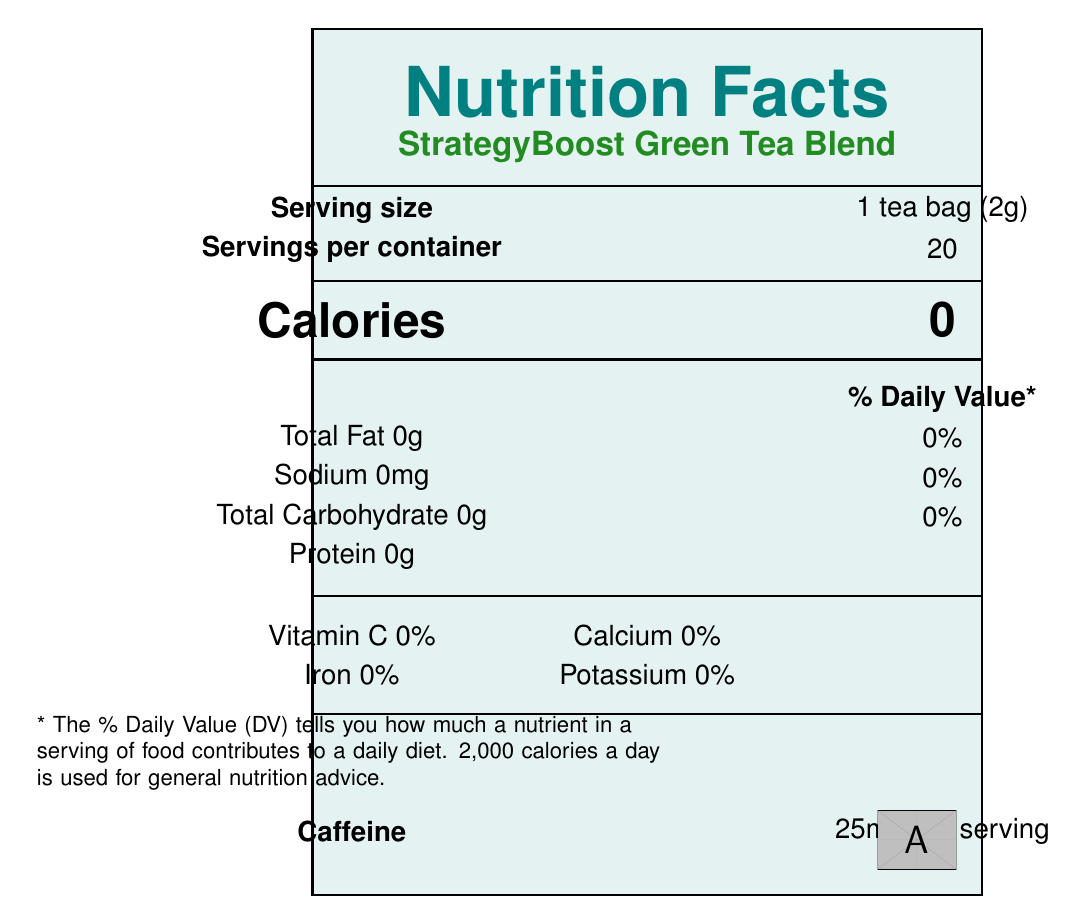What is the serving size of StrategyBoost Green Tea Blend? The serving size is explicitly mentioned as "1 tea bag (2g)" on the document.
Answer: 1 tea bag (2g) How many calories are there per serving? The calorie count is listed as 0 calories per serving.
Answer: 0 How much caffeine is there per serving? The caffeine content per serving is stated as "25mg per serving".
Answer: 25mg What are the primary ingredients in the StrategyBoost Green Tea Blend? The ingredients are listed clearly under the "Ingredients" section.
Answer: Organic green tea leaves, Ginkgo biloba leaf extract, Ashwagandha root powder, L-theanine, Lemon balm leaf, Rhodiola rosea root extract, Natural lemon flavor What is the storage instruction for this green tea blend? The storage instruction is specified in the document.
Answer: Store in a cool, dry place away from direct sunlight. How many servings are there in one container? A. 10 B. 15 C. 20 D. 25 The document states that there are 20 servings per container.
Answer: C. 20 Which of the following vitamins and minerals are present in this tea blend? I. Vitamin C II. Calcium III. Iron IV. Vitamin D The document lists Vitamin C, Calcium, and Iron, each with 0%, but does not mention Vitamin D.
Answer: I, II, and III Is this tea blend considered a significant source of dietary fiber? The disclaimers section mentions that it is "Not a significant source of dietary fiber".
Answer: No Does this product contain any artificial colors, flavors, or preservatives? The special features section specifies that the product contains "No artificial colors, flavors, or preservatives".
Answer: No Summarize the main nutritional characteristics and special features of StrategyBoost Green Tea Blend. The main characteristics include its calorie-free and caffeine-containing formula, which is designed to enhance mental clarity and reduce stress. It is composed of natural ingredients and is free from artificial additives, making it suitable for health-conscious consumers.
Answer: The StrategyBoost Green Tea Blend is a specially formulated green tea that promotes mental clarity and stress reduction, with each serving containing 0 calories and 25mg of caffeine. It includes organic ingredients like green tea leaves, Ginkgo biloba, and Rhodiola rosea root extract. The product is low in caffeine to promote alertness without jitters and does not contain significant vitamins and minerals. It is certified as USDA Organic, Non-GMO, and Kosher. What is the contact phone number for the manufacturer of this tea blend? The manufacturer information section lists the contact phone number.
Answer: 1-800-STRAT-TEA Where is the manufacturer of StrategyBoost Green Tea Blend located? The manufacturer's address is provided in the manufacturer info section.
Answer: 123 Innovation Drive, Silicon Valley, CA 94025 Are there any sugars, including added sugars, in this tea blend? The disclaimers section specifies that it is "Not a significant source... of total sugars, added sugars..."
Answer: No What percentage of Daily Value for Calcium does this tea blend provide? The document indicates that the tea blend provides 0% of the Daily Value for Calcium.
Answer: 0% What is the quantity of protein per serving in the StrategyBoost Green Tea Blend? The amount of protein per serving is listed as 0g.
Answer: 0g What is the batch code of this product? The security features section mentions the batch code as SB2023051501.
Answer: SB2023051501 Which certification(s) do(es) the StrategyBoost Green Tea Blend have? The certifications for the product are clearly listed in the document.
Answer: USDA Organic, Non-GMO Project Verified, Kosher What is the QR code used for? The QR code is provided to verify the batch code "SB2023051501", implying it is used to verify product authenticity.
Answer: Verify product authenticity 